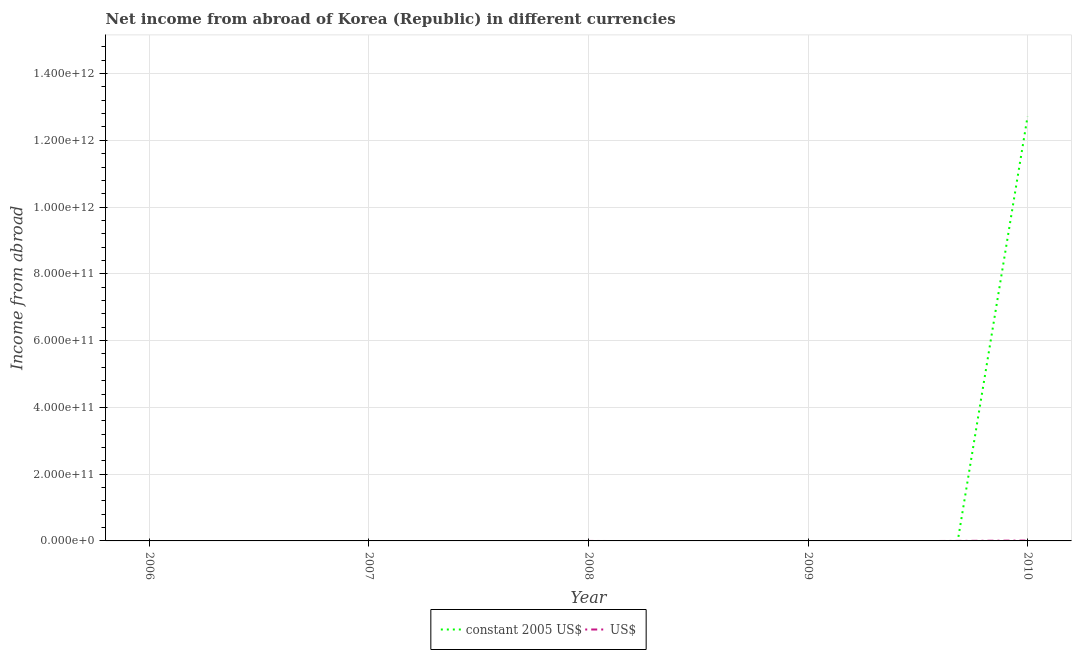Is the number of lines equal to the number of legend labels?
Ensure brevity in your answer.  No. What is the income from abroad in constant 2005 us$ in 2009?
Keep it short and to the point. 0. Across all years, what is the maximum income from abroad in constant 2005 us$?
Make the answer very short. 1.27e+12. What is the total income from abroad in us$ in the graph?
Your answer should be compact. 1.10e+09. What is the difference between the income from abroad in us$ in 2009 and the income from abroad in constant 2005 us$ in 2010?
Provide a short and direct response. -1.27e+12. What is the average income from abroad in constant 2005 us$ per year?
Provide a succinct answer. 2.54e+11. In the year 2010, what is the difference between the income from abroad in us$ and income from abroad in constant 2005 us$?
Ensure brevity in your answer.  -1.27e+12. What is the difference between the highest and the lowest income from abroad in us$?
Your answer should be very brief. 1.10e+09. Does the income from abroad in constant 2005 us$ monotonically increase over the years?
Provide a succinct answer. No. Is the income from abroad in constant 2005 us$ strictly greater than the income from abroad in us$ over the years?
Your response must be concise. No. How many lines are there?
Ensure brevity in your answer.  2. What is the difference between two consecutive major ticks on the Y-axis?
Your answer should be compact. 2.00e+11. Are the values on the major ticks of Y-axis written in scientific E-notation?
Provide a succinct answer. Yes. Does the graph contain any zero values?
Offer a very short reply. Yes. How are the legend labels stacked?
Your answer should be compact. Horizontal. What is the title of the graph?
Your answer should be very brief. Net income from abroad of Korea (Republic) in different currencies. Does "Netherlands" appear as one of the legend labels in the graph?
Your answer should be compact. No. What is the label or title of the Y-axis?
Your answer should be very brief. Income from abroad. What is the Income from abroad in constant 2005 US$ in 2006?
Provide a short and direct response. 0. What is the Income from abroad of constant 2005 US$ in 2007?
Provide a succinct answer. 0. What is the Income from abroad of US$ in 2008?
Provide a succinct answer. 0. What is the Income from abroad of constant 2005 US$ in 2009?
Make the answer very short. 0. What is the Income from abroad of US$ in 2009?
Provide a short and direct response. 0. What is the Income from abroad in constant 2005 US$ in 2010?
Provide a succinct answer. 1.27e+12. What is the Income from abroad in US$ in 2010?
Your answer should be very brief. 1.10e+09. Across all years, what is the maximum Income from abroad in constant 2005 US$?
Your answer should be very brief. 1.27e+12. Across all years, what is the maximum Income from abroad in US$?
Ensure brevity in your answer.  1.10e+09. Across all years, what is the minimum Income from abroad in constant 2005 US$?
Give a very brief answer. 0. Across all years, what is the minimum Income from abroad of US$?
Ensure brevity in your answer.  0. What is the total Income from abroad in constant 2005 US$ in the graph?
Your answer should be compact. 1.27e+12. What is the total Income from abroad in US$ in the graph?
Make the answer very short. 1.10e+09. What is the average Income from abroad of constant 2005 US$ per year?
Ensure brevity in your answer.  2.54e+11. What is the average Income from abroad in US$ per year?
Provide a succinct answer. 2.20e+08. In the year 2010, what is the difference between the Income from abroad in constant 2005 US$ and Income from abroad in US$?
Make the answer very short. 1.27e+12. What is the difference between the highest and the lowest Income from abroad of constant 2005 US$?
Provide a succinct answer. 1.27e+12. What is the difference between the highest and the lowest Income from abroad of US$?
Give a very brief answer. 1.10e+09. 